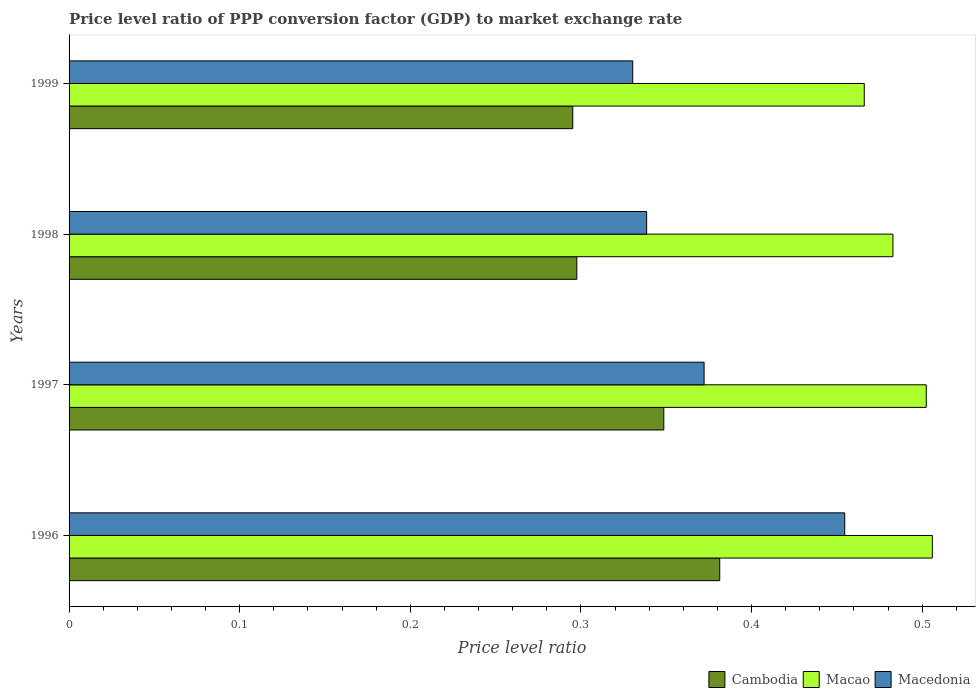How many groups of bars are there?
Your answer should be very brief. 4. Are the number of bars per tick equal to the number of legend labels?
Ensure brevity in your answer.  Yes. How many bars are there on the 1st tick from the top?
Your response must be concise. 3. What is the label of the 2nd group of bars from the top?
Provide a short and direct response. 1998. What is the price level ratio in Cambodia in 1999?
Ensure brevity in your answer.  0.3. Across all years, what is the maximum price level ratio in Macao?
Ensure brevity in your answer.  0.51. Across all years, what is the minimum price level ratio in Macedonia?
Give a very brief answer. 0.33. In which year was the price level ratio in Macao maximum?
Give a very brief answer. 1996. What is the total price level ratio in Macedonia in the graph?
Offer a very short reply. 1.5. What is the difference between the price level ratio in Macao in 1996 and that in 1998?
Offer a very short reply. 0.02. What is the difference between the price level ratio in Macao in 1996 and the price level ratio in Macedonia in 1998?
Give a very brief answer. 0.17. What is the average price level ratio in Cambodia per year?
Ensure brevity in your answer.  0.33. In the year 1996, what is the difference between the price level ratio in Macao and price level ratio in Cambodia?
Give a very brief answer. 0.12. In how many years, is the price level ratio in Macao greater than 0.14 ?
Provide a succinct answer. 4. What is the ratio of the price level ratio in Macedonia in 1997 to that in 1998?
Your response must be concise. 1.1. Is the price level ratio in Cambodia in 1997 less than that in 1999?
Provide a short and direct response. No. What is the difference between the highest and the second highest price level ratio in Cambodia?
Provide a short and direct response. 0.03. What is the difference between the highest and the lowest price level ratio in Macao?
Give a very brief answer. 0.04. What does the 2nd bar from the top in 1996 represents?
Offer a very short reply. Macao. What does the 2nd bar from the bottom in 1997 represents?
Provide a short and direct response. Macao. How many bars are there?
Ensure brevity in your answer.  12. Are all the bars in the graph horizontal?
Ensure brevity in your answer.  Yes. How many years are there in the graph?
Offer a terse response. 4. Are the values on the major ticks of X-axis written in scientific E-notation?
Ensure brevity in your answer.  No. Does the graph contain grids?
Provide a succinct answer. No. How are the legend labels stacked?
Provide a succinct answer. Horizontal. What is the title of the graph?
Offer a very short reply. Price level ratio of PPP conversion factor (GDP) to market exchange rate. Does "Armenia" appear as one of the legend labels in the graph?
Your answer should be very brief. No. What is the label or title of the X-axis?
Your answer should be compact. Price level ratio. What is the label or title of the Y-axis?
Provide a short and direct response. Years. What is the Price level ratio in Cambodia in 1996?
Ensure brevity in your answer.  0.38. What is the Price level ratio in Macao in 1996?
Ensure brevity in your answer.  0.51. What is the Price level ratio of Macedonia in 1996?
Provide a short and direct response. 0.45. What is the Price level ratio of Cambodia in 1997?
Your answer should be compact. 0.35. What is the Price level ratio in Macao in 1997?
Offer a very short reply. 0.5. What is the Price level ratio of Macedonia in 1997?
Make the answer very short. 0.37. What is the Price level ratio of Cambodia in 1998?
Offer a very short reply. 0.3. What is the Price level ratio of Macao in 1998?
Offer a very short reply. 0.48. What is the Price level ratio in Macedonia in 1998?
Your answer should be compact. 0.34. What is the Price level ratio in Cambodia in 1999?
Keep it short and to the point. 0.3. What is the Price level ratio in Macao in 1999?
Ensure brevity in your answer.  0.47. What is the Price level ratio of Macedonia in 1999?
Provide a short and direct response. 0.33. Across all years, what is the maximum Price level ratio of Cambodia?
Your response must be concise. 0.38. Across all years, what is the maximum Price level ratio in Macao?
Your answer should be very brief. 0.51. Across all years, what is the maximum Price level ratio of Macedonia?
Your answer should be compact. 0.45. Across all years, what is the minimum Price level ratio of Cambodia?
Offer a terse response. 0.3. Across all years, what is the minimum Price level ratio of Macao?
Your response must be concise. 0.47. Across all years, what is the minimum Price level ratio of Macedonia?
Your answer should be very brief. 0.33. What is the total Price level ratio in Cambodia in the graph?
Make the answer very short. 1.32. What is the total Price level ratio of Macao in the graph?
Provide a succinct answer. 1.96. What is the total Price level ratio in Macedonia in the graph?
Make the answer very short. 1.5. What is the difference between the Price level ratio of Cambodia in 1996 and that in 1997?
Make the answer very short. 0.03. What is the difference between the Price level ratio in Macao in 1996 and that in 1997?
Provide a succinct answer. 0. What is the difference between the Price level ratio in Macedonia in 1996 and that in 1997?
Your answer should be compact. 0.08. What is the difference between the Price level ratio in Cambodia in 1996 and that in 1998?
Your response must be concise. 0.08. What is the difference between the Price level ratio of Macao in 1996 and that in 1998?
Give a very brief answer. 0.02. What is the difference between the Price level ratio in Macedonia in 1996 and that in 1998?
Your response must be concise. 0.12. What is the difference between the Price level ratio of Cambodia in 1996 and that in 1999?
Keep it short and to the point. 0.09. What is the difference between the Price level ratio in Macao in 1996 and that in 1999?
Offer a very short reply. 0.04. What is the difference between the Price level ratio of Macedonia in 1996 and that in 1999?
Your response must be concise. 0.12. What is the difference between the Price level ratio in Cambodia in 1997 and that in 1998?
Make the answer very short. 0.05. What is the difference between the Price level ratio of Macao in 1997 and that in 1998?
Ensure brevity in your answer.  0.02. What is the difference between the Price level ratio in Macedonia in 1997 and that in 1998?
Keep it short and to the point. 0.03. What is the difference between the Price level ratio of Cambodia in 1997 and that in 1999?
Provide a short and direct response. 0.05. What is the difference between the Price level ratio in Macao in 1997 and that in 1999?
Give a very brief answer. 0.04. What is the difference between the Price level ratio in Macedonia in 1997 and that in 1999?
Offer a very short reply. 0.04. What is the difference between the Price level ratio of Cambodia in 1998 and that in 1999?
Provide a short and direct response. 0. What is the difference between the Price level ratio of Macao in 1998 and that in 1999?
Give a very brief answer. 0.02. What is the difference between the Price level ratio of Macedonia in 1998 and that in 1999?
Ensure brevity in your answer.  0.01. What is the difference between the Price level ratio of Cambodia in 1996 and the Price level ratio of Macao in 1997?
Provide a succinct answer. -0.12. What is the difference between the Price level ratio of Cambodia in 1996 and the Price level ratio of Macedonia in 1997?
Make the answer very short. 0.01. What is the difference between the Price level ratio in Macao in 1996 and the Price level ratio in Macedonia in 1997?
Make the answer very short. 0.13. What is the difference between the Price level ratio of Cambodia in 1996 and the Price level ratio of Macao in 1998?
Offer a very short reply. -0.1. What is the difference between the Price level ratio in Cambodia in 1996 and the Price level ratio in Macedonia in 1998?
Your answer should be compact. 0.04. What is the difference between the Price level ratio in Macao in 1996 and the Price level ratio in Macedonia in 1998?
Provide a succinct answer. 0.17. What is the difference between the Price level ratio in Cambodia in 1996 and the Price level ratio in Macao in 1999?
Your response must be concise. -0.08. What is the difference between the Price level ratio of Cambodia in 1996 and the Price level ratio of Macedonia in 1999?
Offer a very short reply. 0.05. What is the difference between the Price level ratio of Macao in 1996 and the Price level ratio of Macedonia in 1999?
Provide a short and direct response. 0.18. What is the difference between the Price level ratio in Cambodia in 1997 and the Price level ratio in Macao in 1998?
Give a very brief answer. -0.13. What is the difference between the Price level ratio in Cambodia in 1997 and the Price level ratio in Macedonia in 1998?
Your answer should be compact. 0.01. What is the difference between the Price level ratio of Macao in 1997 and the Price level ratio of Macedonia in 1998?
Ensure brevity in your answer.  0.16. What is the difference between the Price level ratio in Cambodia in 1997 and the Price level ratio in Macao in 1999?
Provide a short and direct response. -0.12. What is the difference between the Price level ratio in Cambodia in 1997 and the Price level ratio in Macedonia in 1999?
Your response must be concise. 0.02. What is the difference between the Price level ratio in Macao in 1997 and the Price level ratio in Macedonia in 1999?
Provide a succinct answer. 0.17. What is the difference between the Price level ratio in Cambodia in 1998 and the Price level ratio in Macao in 1999?
Your response must be concise. -0.17. What is the difference between the Price level ratio of Cambodia in 1998 and the Price level ratio of Macedonia in 1999?
Provide a short and direct response. -0.03. What is the difference between the Price level ratio of Macao in 1998 and the Price level ratio of Macedonia in 1999?
Offer a terse response. 0.15. What is the average Price level ratio in Cambodia per year?
Provide a succinct answer. 0.33. What is the average Price level ratio in Macao per year?
Your response must be concise. 0.49. What is the average Price level ratio in Macedonia per year?
Give a very brief answer. 0.37. In the year 1996, what is the difference between the Price level ratio in Cambodia and Price level ratio in Macao?
Ensure brevity in your answer.  -0.12. In the year 1996, what is the difference between the Price level ratio in Cambodia and Price level ratio in Macedonia?
Your response must be concise. -0.07. In the year 1996, what is the difference between the Price level ratio in Macao and Price level ratio in Macedonia?
Give a very brief answer. 0.05. In the year 1997, what is the difference between the Price level ratio of Cambodia and Price level ratio of Macao?
Ensure brevity in your answer.  -0.15. In the year 1997, what is the difference between the Price level ratio of Cambodia and Price level ratio of Macedonia?
Make the answer very short. -0.02. In the year 1997, what is the difference between the Price level ratio in Macao and Price level ratio in Macedonia?
Provide a succinct answer. 0.13. In the year 1998, what is the difference between the Price level ratio in Cambodia and Price level ratio in Macao?
Your response must be concise. -0.19. In the year 1998, what is the difference between the Price level ratio in Cambodia and Price level ratio in Macedonia?
Offer a very short reply. -0.04. In the year 1998, what is the difference between the Price level ratio in Macao and Price level ratio in Macedonia?
Your answer should be very brief. 0.14. In the year 1999, what is the difference between the Price level ratio in Cambodia and Price level ratio in Macao?
Your answer should be very brief. -0.17. In the year 1999, what is the difference between the Price level ratio in Cambodia and Price level ratio in Macedonia?
Offer a very short reply. -0.04. In the year 1999, what is the difference between the Price level ratio in Macao and Price level ratio in Macedonia?
Ensure brevity in your answer.  0.14. What is the ratio of the Price level ratio of Cambodia in 1996 to that in 1997?
Give a very brief answer. 1.09. What is the ratio of the Price level ratio of Macao in 1996 to that in 1997?
Keep it short and to the point. 1.01. What is the ratio of the Price level ratio of Macedonia in 1996 to that in 1997?
Provide a short and direct response. 1.22. What is the ratio of the Price level ratio of Cambodia in 1996 to that in 1998?
Offer a terse response. 1.28. What is the ratio of the Price level ratio of Macao in 1996 to that in 1998?
Offer a very short reply. 1.05. What is the ratio of the Price level ratio in Macedonia in 1996 to that in 1998?
Your answer should be very brief. 1.34. What is the ratio of the Price level ratio in Cambodia in 1996 to that in 1999?
Make the answer very short. 1.29. What is the ratio of the Price level ratio of Macao in 1996 to that in 1999?
Your answer should be compact. 1.09. What is the ratio of the Price level ratio in Macedonia in 1996 to that in 1999?
Make the answer very short. 1.38. What is the ratio of the Price level ratio of Cambodia in 1997 to that in 1998?
Your response must be concise. 1.17. What is the ratio of the Price level ratio in Macao in 1997 to that in 1998?
Give a very brief answer. 1.04. What is the ratio of the Price level ratio in Macedonia in 1997 to that in 1998?
Keep it short and to the point. 1.1. What is the ratio of the Price level ratio in Cambodia in 1997 to that in 1999?
Offer a terse response. 1.18. What is the ratio of the Price level ratio of Macao in 1997 to that in 1999?
Provide a succinct answer. 1.08. What is the ratio of the Price level ratio of Macedonia in 1997 to that in 1999?
Keep it short and to the point. 1.13. What is the ratio of the Price level ratio of Macao in 1998 to that in 1999?
Your answer should be very brief. 1.04. What is the ratio of the Price level ratio of Macedonia in 1998 to that in 1999?
Keep it short and to the point. 1.02. What is the difference between the highest and the second highest Price level ratio in Cambodia?
Your answer should be compact. 0.03. What is the difference between the highest and the second highest Price level ratio of Macao?
Provide a short and direct response. 0. What is the difference between the highest and the second highest Price level ratio in Macedonia?
Ensure brevity in your answer.  0.08. What is the difference between the highest and the lowest Price level ratio of Cambodia?
Your answer should be compact. 0.09. What is the difference between the highest and the lowest Price level ratio of Macao?
Provide a succinct answer. 0.04. What is the difference between the highest and the lowest Price level ratio of Macedonia?
Offer a very short reply. 0.12. 